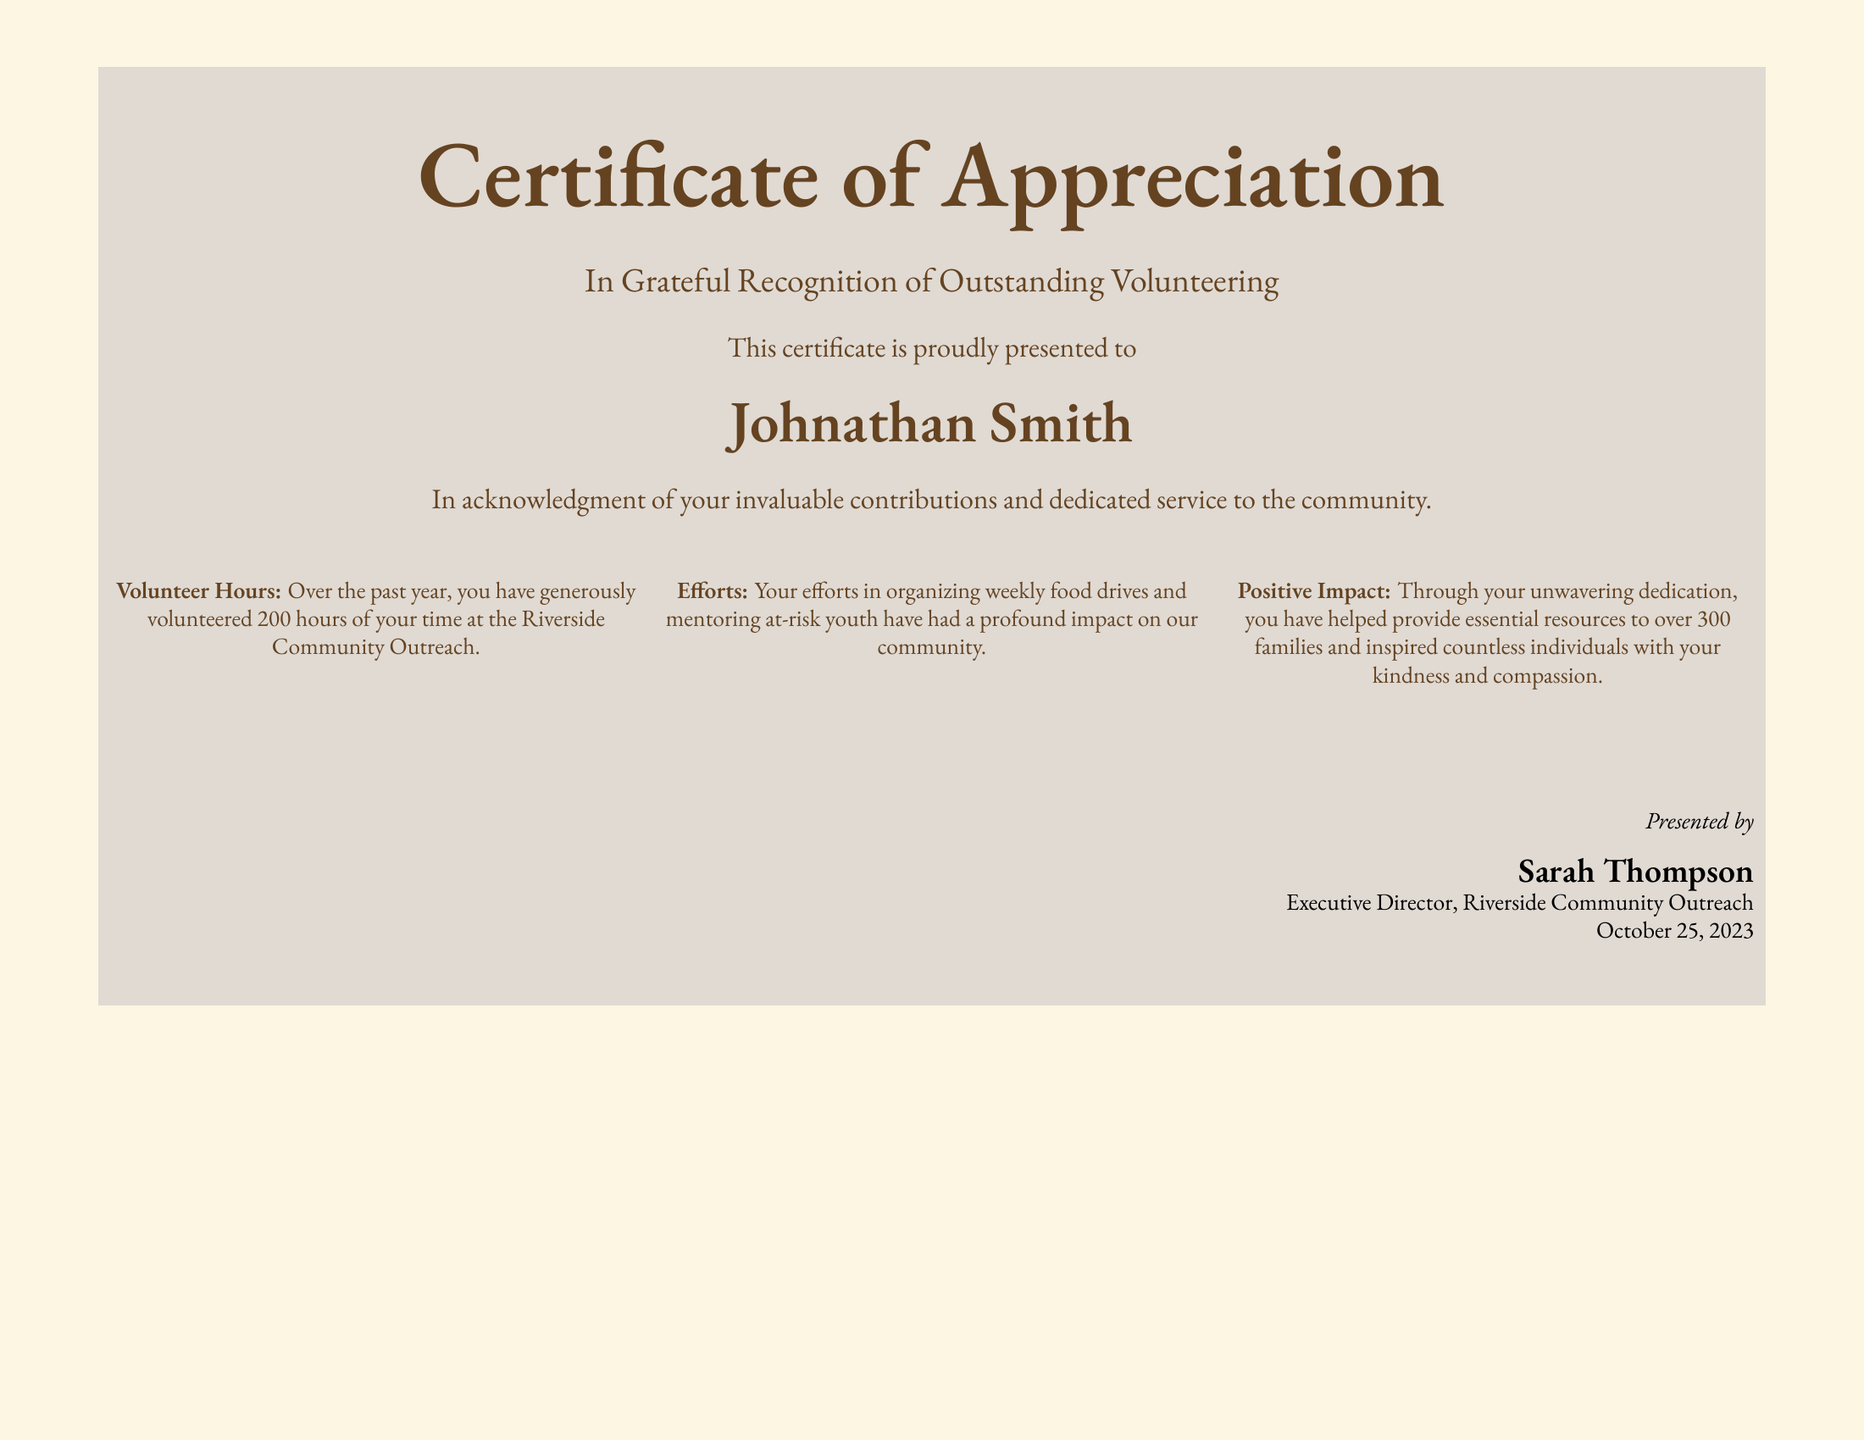What is the title of the document? The title is presented prominently at the top of the document.
Answer: Certificate of Appreciation Who is the certificate presented to? The document states the recipient's name prominently in a larger font.
Answer: Johnathan Smith How many volunteer hours did Johnathan Smith contribute? The number of hours volunteered is explicitly mentioned in one section of the document.
Answer: 200 hours What organization did Johnathan Smith volunteer for? The organization is stated clearly within the document.
Answer: Riverside Community Outreach Who signed the certificate? The signature line includes the name of the person who presented the certificate.
Answer: Sarah Thompson When was the certificate presented? The date is specified at the bottom of the document.
Answer: October 25, 2023 What were the efforts acknowledged in the certificate? The document lists specific activities that were recognized.
Answer: Organizing weekly food drives and mentoring at-risk youth How many families benefited from Johnathan Smith's efforts? The document gives a specific number in reference to the impact on families.
Answer: Over 300 families What is the primary purpose of this certificate? The main purpose of the certificate is explained in the introductory text.
Answer: Recognition of outstanding volunteering 